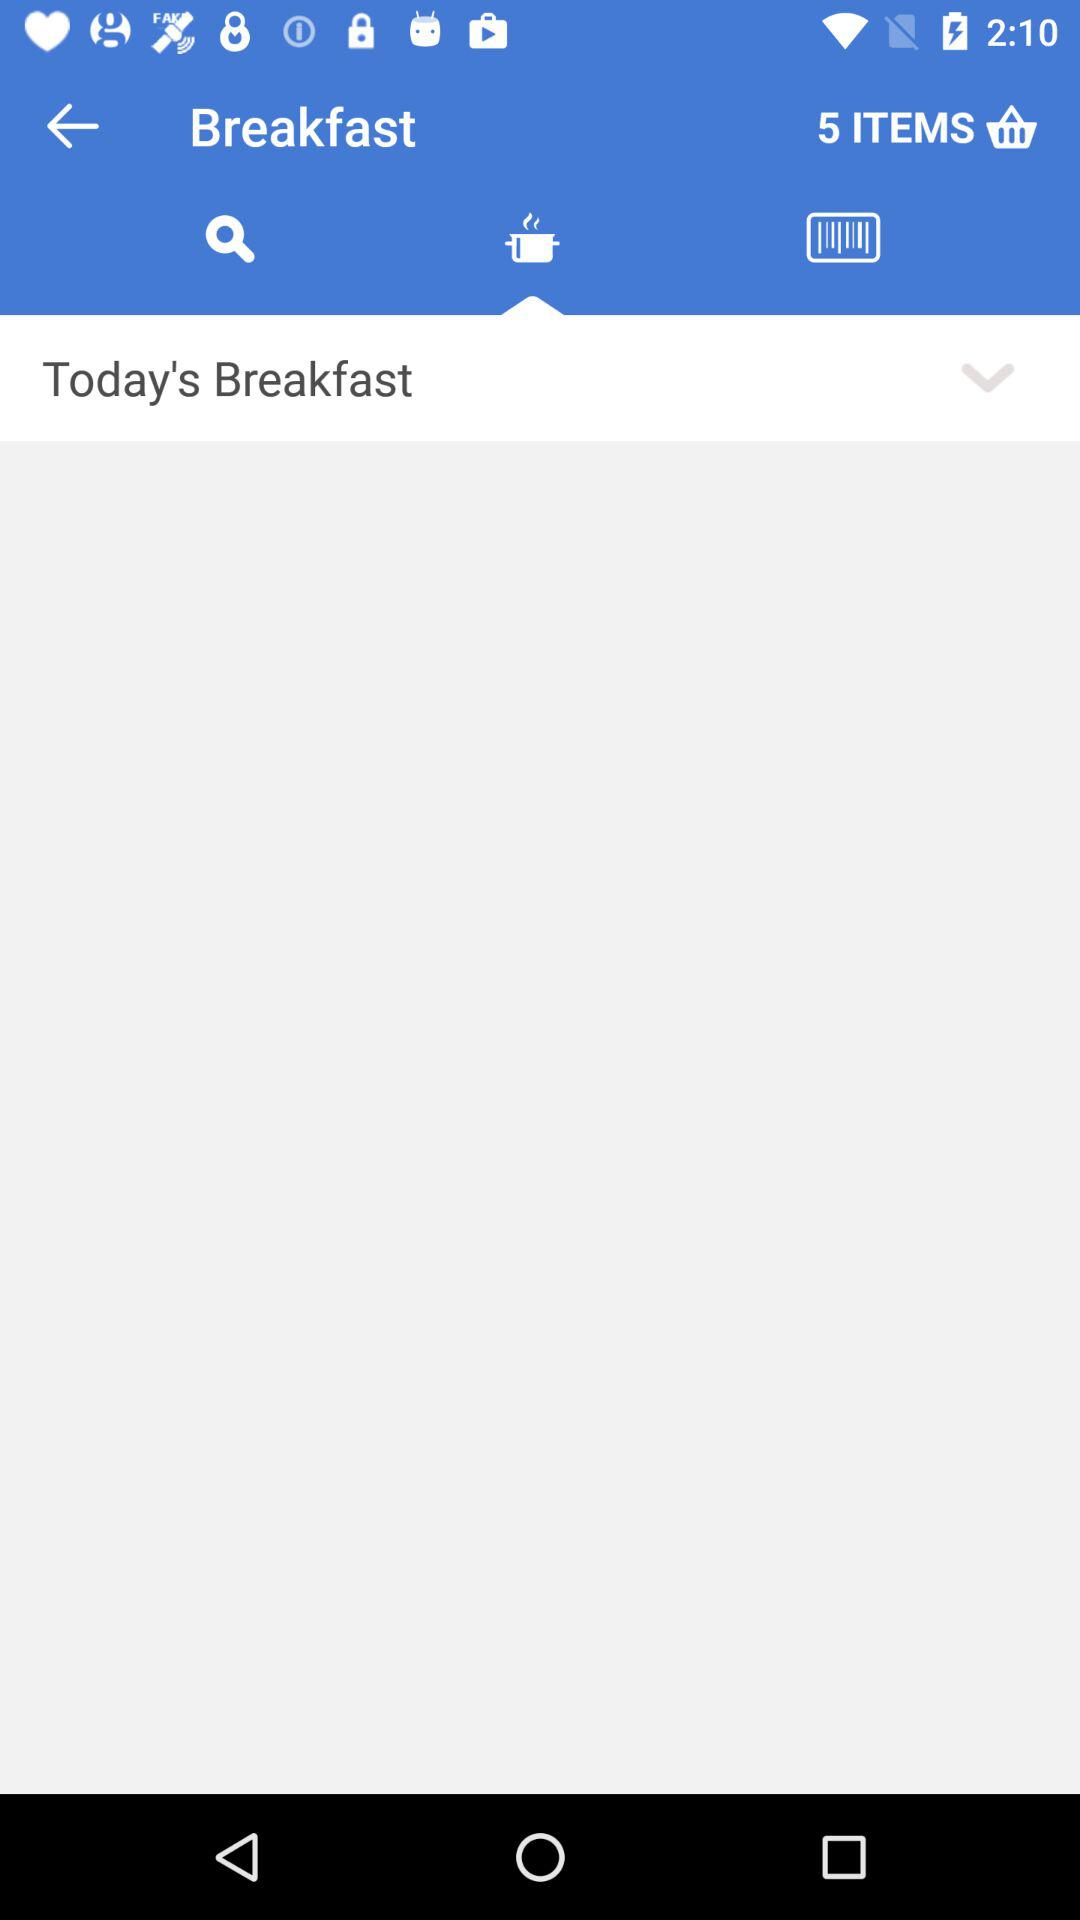How many items are there in the cart? There are 5 items in the cart. 